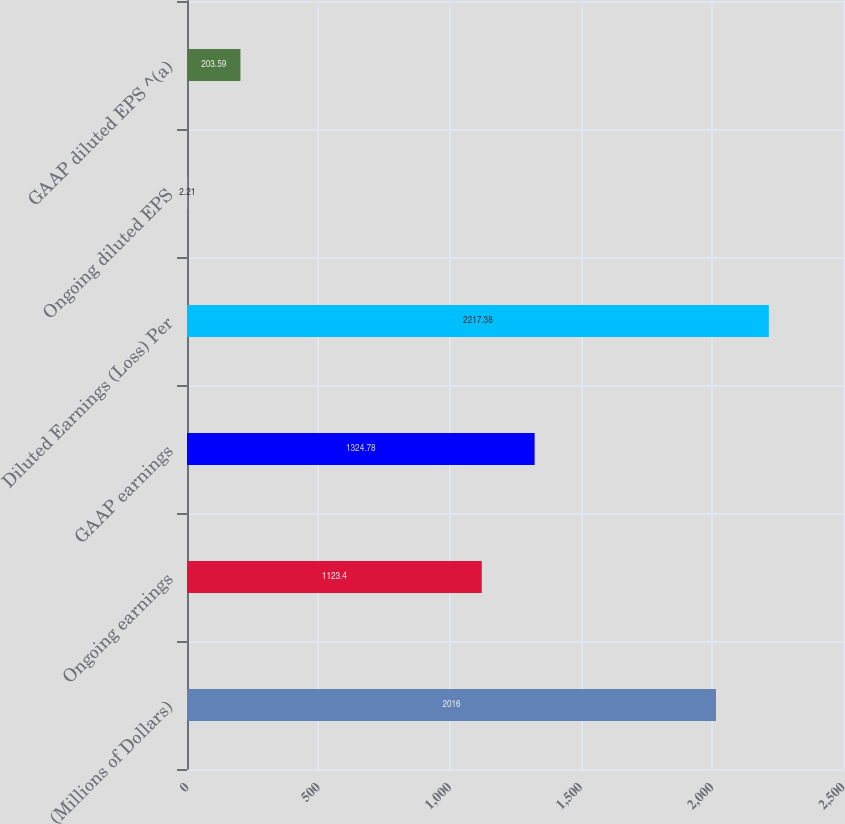<chart> <loc_0><loc_0><loc_500><loc_500><bar_chart><fcel>(Millions of Dollars)<fcel>Ongoing earnings<fcel>GAAP earnings<fcel>Diluted Earnings (Loss) Per<fcel>Ongoing diluted EPS<fcel>GAAP diluted EPS ^(a)<nl><fcel>2016<fcel>1123.4<fcel>1324.78<fcel>2217.38<fcel>2.21<fcel>203.59<nl></chart> 